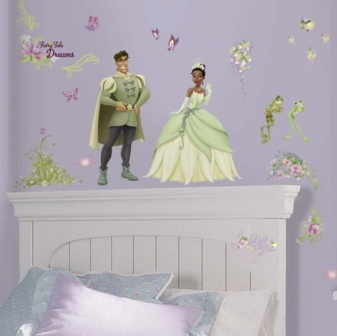How might this room decor affect the imagination and creativity of a child living here? The enchanting decor of this room can significantly stimulate a child's imagination and creativity. Surrounded by images of princes, princesses, magical frogs, and fluttering butterflies, a child is likely to concoct numerous narratives and imaginative games. This environment fosters a sense of wonder and adventure, encouraging the child to engage in imaginative play, dream up fairy-tale stories, and perhaps even inspire an interest in reading and storytelling. Overall, such a creatively stimulating bedroom can nurture cognitive development and artistic expression. 